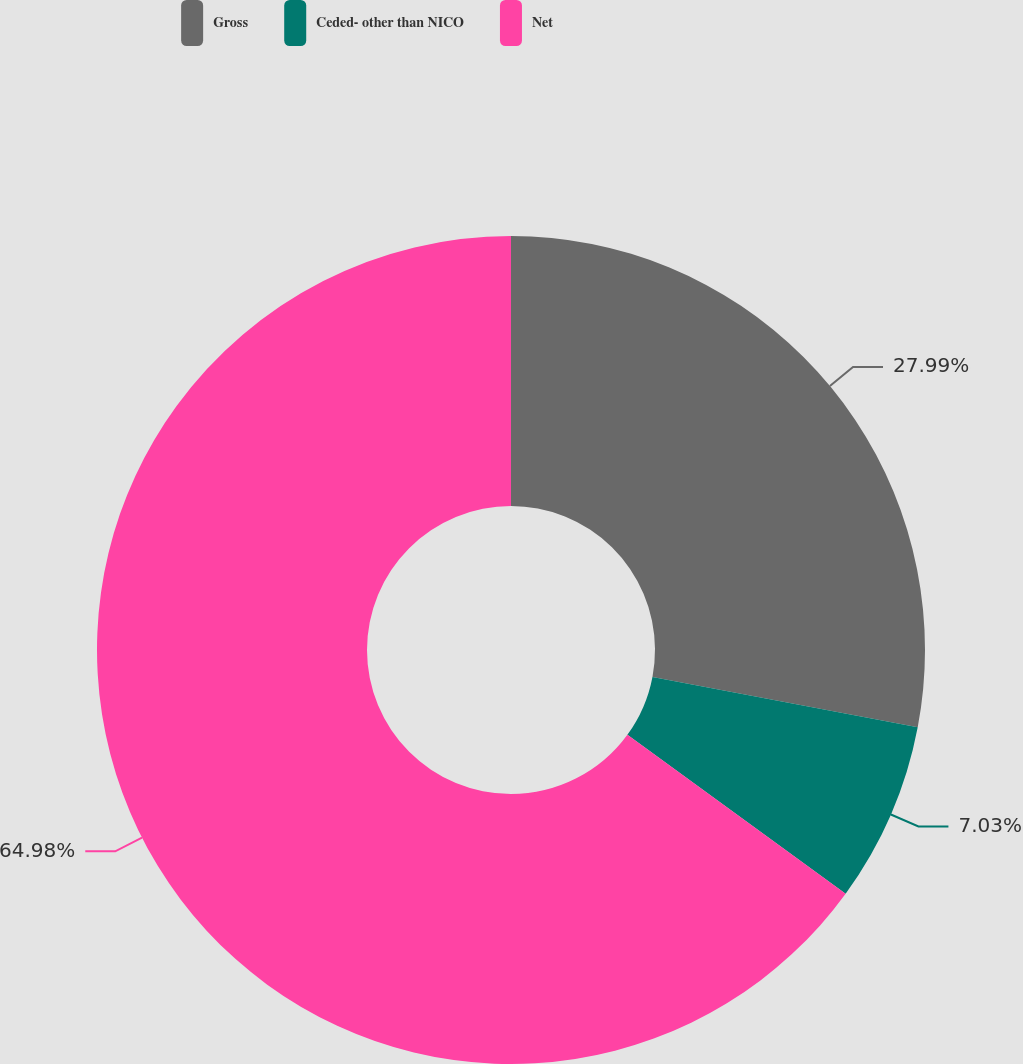Convert chart. <chart><loc_0><loc_0><loc_500><loc_500><pie_chart><fcel>Gross<fcel>Ceded- other than NICO<fcel>Net<nl><fcel>27.99%<fcel>7.03%<fcel>64.98%<nl></chart> 